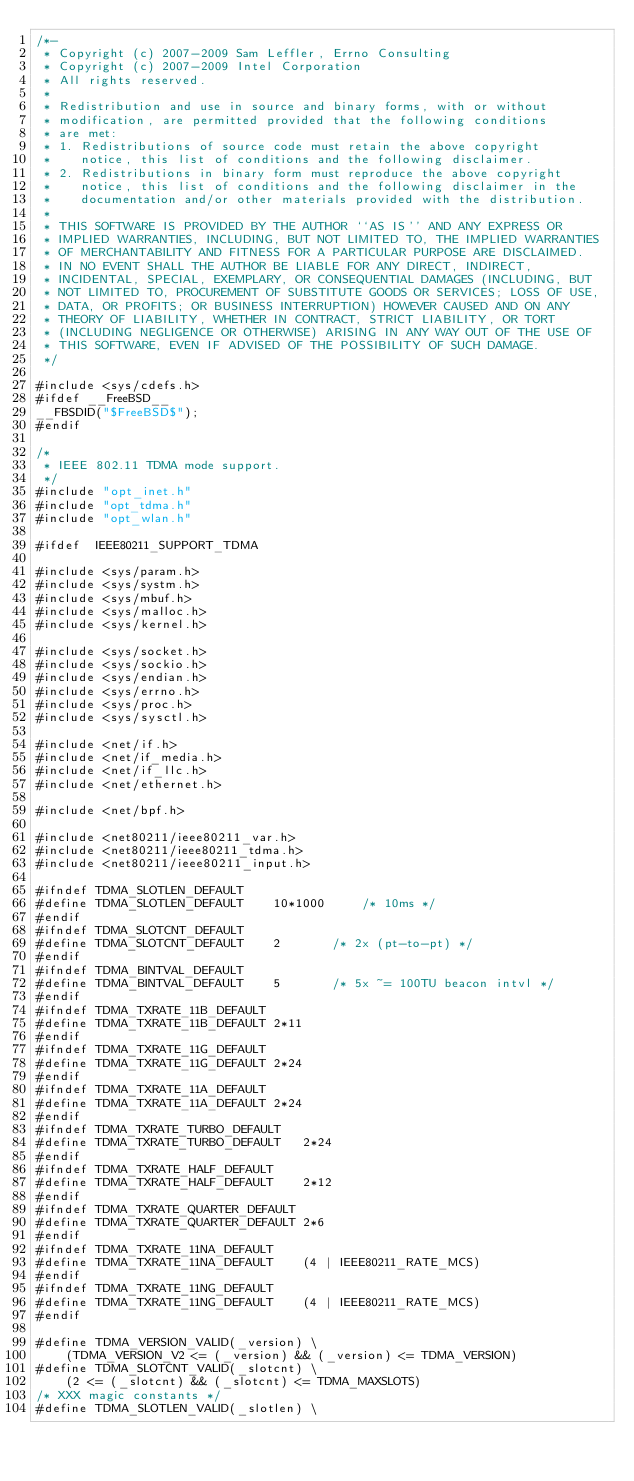Convert code to text. <code><loc_0><loc_0><loc_500><loc_500><_C_>/*-
 * Copyright (c) 2007-2009 Sam Leffler, Errno Consulting
 * Copyright (c) 2007-2009 Intel Corporation
 * All rights reserved.
 *
 * Redistribution and use in source and binary forms, with or without
 * modification, are permitted provided that the following conditions
 * are met:
 * 1. Redistributions of source code must retain the above copyright
 *    notice, this list of conditions and the following disclaimer.
 * 2. Redistributions in binary form must reproduce the above copyright
 *    notice, this list of conditions and the following disclaimer in the
 *    documentation and/or other materials provided with the distribution.
 *
 * THIS SOFTWARE IS PROVIDED BY THE AUTHOR ``AS IS'' AND ANY EXPRESS OR
 * IMPLIED WARRANTIES, INCLUDING, BUT NOT LIMITED TO, THE IMPLIED WARRANTIES
 * OF MERCHANTABILITY AND FITNESS FOR A PARTICULAR PURPOSE ARE DISCLAIMED.
 * IN NO EVENT SHALL THE AUTHOR BE LIABLE FOR ANY DIRECT, INDIRECT,
 * INCIDENTAL, SPECIAL, EXEMPLARY, OR CONSEQUENTIAL DAMAGES (INCLUDING, BUT
 * NOT LIMITED TO, PROCUREMENT OF SUBSTITUTE GOODS OR SERVICES; LOSS OF USE,
 * DATA, OR PROFITS; OR BUSINESS INTERRUPTION) HOWEVER CAUSED AND ON ANY
 * THEORY OF LIABILITY, WHETHER IN CONTRACT, STRICT LIABILITY, OR TORT
 * (INCLUDING NEGLIGENCE OR OTHERWISE) ARISING IN ANY WAY OUT OF THE USE OF
 * THIS SOFTWARE, EVEN IF ADVISED OF THE POSSIBILITY OF SUCH DAMAGE.
 */

#include <sys/cdefs.h>
#ifdef __FreeBSD__
__FBSDID("$FreeBSD$");
#endif

/*
 * IEEE 802.11 TDMA mode support.
 */
#include "opt_inet.h"
#include "opt_tdma.h"
#include "opt_wlan.h"

#ifdef	IEEE80211_SUPPORT_TDMA

#include <sys/param.h>
#include <sys/systm.h> 
#include <sys/mbuf.h>   
#include <sys/malloc.h>
#include <sys/kernel.h>

#include <sys/socket.h>
#include <sys/sockio.h>
#include <sys/endian.h>
#include <sys/errno.h>
#include <sys/proc.h>
#include <sys/sysctl.h>

#include <net/if.h>
#include <net/if_media.h>
#include <net/if_llc.h>
#include <net/ethernet.h>

#include <net/bpf.h>

#include <net80211/ieee80211_var.h>
#include <net80211/ieee80211_tdma.h>
#include <net80211/ieee80211_input.h>

#ifndef TDMA_SLOTLEN_DEFAULT
#define	TDMA_SLOTLEN_DEFAULT	10*1000		/* 10ms */
#endif
#ifndef TDMA_SLOTCNT_DEFAULT
#define	TDMA_SLOTCNT_DEFAULT	2		/* 2x (pt-to-pt) */
#endif
#ifndef TDMA_BINTVAL_DEFAULT
#define	TDMA_BINTVAL_DEFAULT	5		/* 5x ~= 100TU beacon intvl */
#endif
#ifndef TDMA_TXRATE_11B_DEFAULT
#define	TDMA_TXRATE_11B_DEFAULT	2*11
#endif
#ifndef TDMA_TXRATE_11G_DEFAULT
#define	TDMA_TXRATE_11G_DEFAULT	2*24
#endif
#ifndef TDMA_TXRATE_11A_DEFAULT
#define	TDMA_TXRATE_11A_DEFAULT	2*24
#endif
#ifndef TDMA_TXRATE_TURBO_DEFAULT
#define	TDMA_TXRATE_TURBO_DEFAULT	2*24
#endif
#ifndef TDMA_TXRATE_HALF_DEFAULT
#define	TDMA_TXRATE_HALF_DEFAULT	2*12
#endif
#ifndef TDMA_TXRATE_QUARTER_DEFAULT
#define	TDMA_TXRATE_QUARTER_DEFAULT	2*6
#endif
#ifndef TDMA_TXRATE_11NA_DEFAULT
#define	TDMA_TXRATE_11NA_DEFAULT	(4 | IEEE80211_RATE_MCS)
#endif
#ifndef TDMA_TXRATE_11NG_DEFAULT
#define	TDMA_TXRATE_11NG_DEFAULT	(4 | IEEE80211_RATE_MCS)
#endif

#define	TDMA_VERSION_VALID(_version) \
	(TDMA_VERSION_V2 <= (_version) && (_version) <= TDMA_VERSION)
#define	TDMA_SLOTCNT_VALID(_slotcnt) \
	(2 <= (_slotcnt) && (_slotcnt) <= TDMA_MAXSLOTS)
/* XXX magic constants */
#define	TDMA_SLOTLEN_VALID(_slotlen) \</code> 